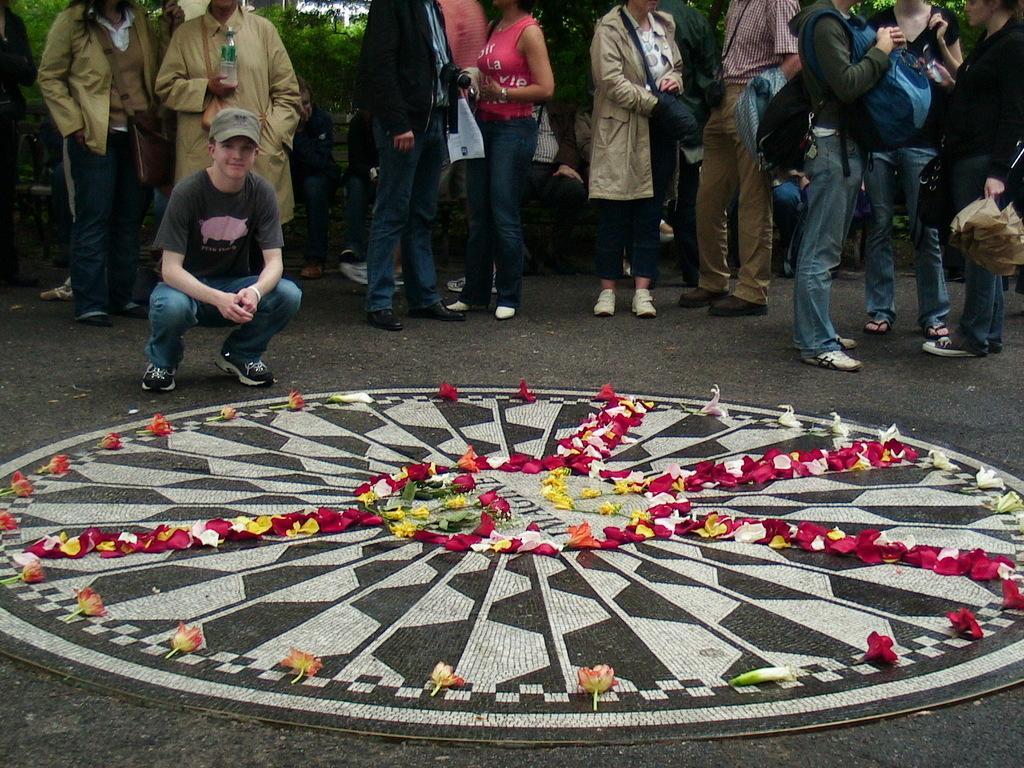In one or two sentences, can you explain what this image depicts? There are people standing and this person sitting like squat position. We can see flowers on the design. In the background we can see trees. 